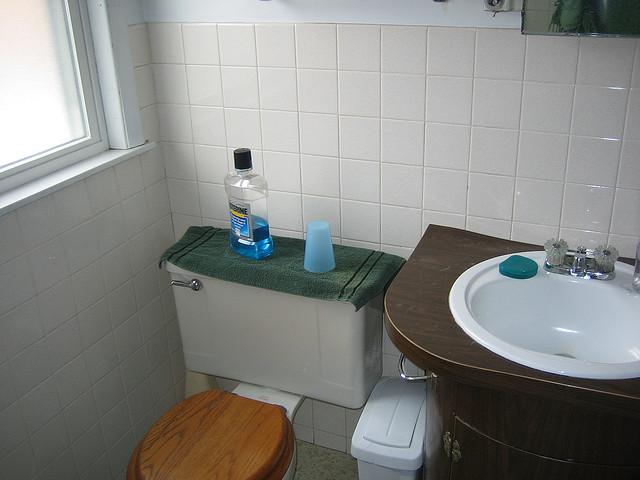Is there a mouthwash on top of the toilet?
Concise answer only. Yes. Is the lid down?
Concise answer only. Yes. What color is the cup?
Be succinct. Blue. 